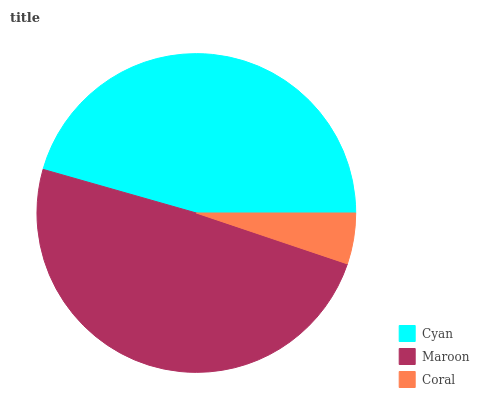Is Coral the minimum?
Answer yes or no. Yes. Is Maroon the maximum?
Answer yes or no. Yes. Is Maroon the minimum?
Answer yes or no. No. Is Coral the maximum?
Answer yes or no. No. Is Maroon greater than Coral?
Answer yes or no. Yes. Is Coral less than Maroon?
Answer yes or no. Yes. Is Coral greater than Maroon?
Answer yes or no. No. Is Maroon less than Coral?
Answer yes or no. No. Is Cyan the high median?
Answer yes or no. Yes. Is Cyan the low median?
Answer yes or no. Yes. Is Coral the high median?
Answer yes or no. No. Is Coral the low median?
Answer yes or no. No. 